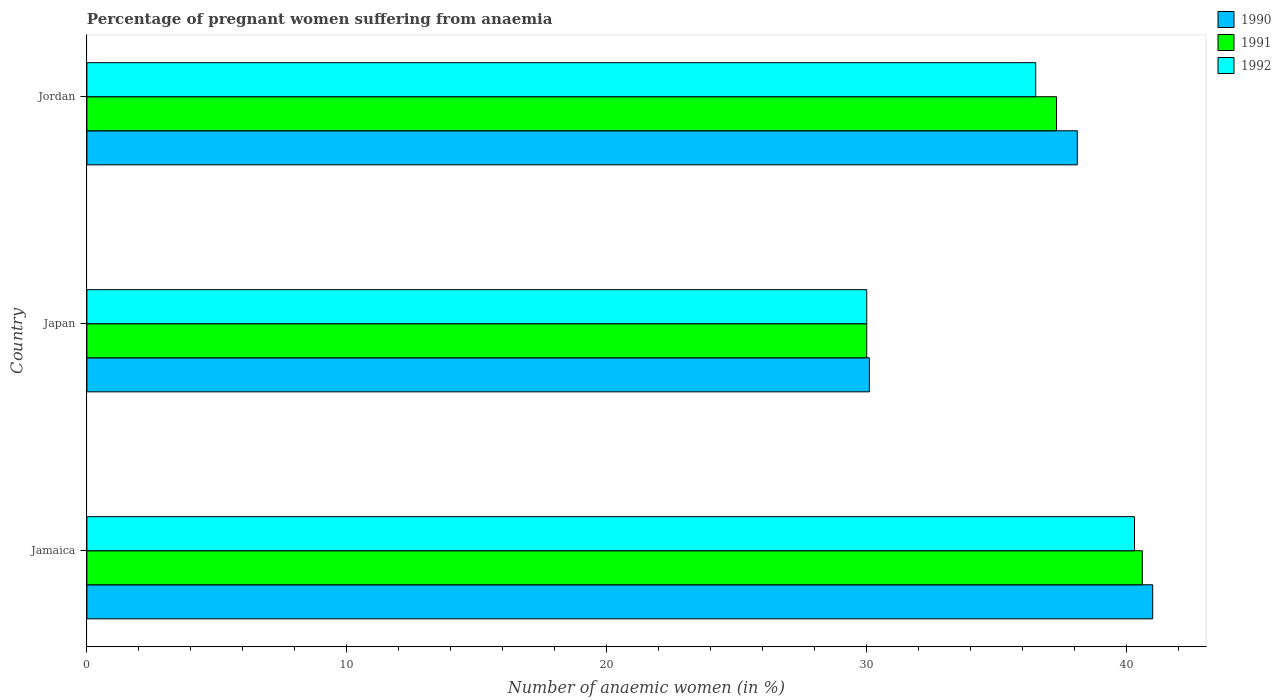How many groups of bars are there?
Make the answer very short. 3. How many bars are there on the 1st tick from the top?
Your response must be concise. 3. What is the label of the 1st group of bars from the top?
Your answer should be compact. Jordan. What is the number of anaemic women in 1990 in Jamaica?
Your answer should be compact. 41. Across all countries, what is the maximum number of anaemic women in 1992?
Ensure brevity in your answer.  40.3. Across all countries, what is the minimum number of anaemic women in 1990?
Your response must be concise. 30.1. In which country was the number of anaemic women in 1991 maximum?
Make the answer very short. Jamaica. What is the total number of anaemic women in 1992 in the graph?
Your answer should be very brief. 106.8. What is the difference between the number of anaemic women in 1991 in Jamaica and that in Jordan?
Your answer should be very brief. 3.3. What is the difference between the number of anaemic women in 1990 in Jordan and the number of anaemic women in 1992 in Japan?
Your answer should be very brief. 8.1. What is the average number of anaemic women in 1991 per country?
Offer a terse response. 35.97. What is the difference between the number of anaemic women in 1992 and number of anaemic women in 1990 in Jamaica?
Give a very brief answer. -0.7. In how many countries, is the number of anaemic women in 1992 greater than 14 %?
Your answer should be very brief. 3. What is the ratio of the number of anaemic women in 1990 in Jamaica to that in Jordan?
Your response must be concise. 1.08. Is the number of anaemic women in 1991 in Jamaica less than that in Jordan?
Keep it short and to the point. No. Is the difference between the number of anaemic women in 1992 in Japan and Jordan greater than the difference between the number of anaemic women in 1990 in Japan and Jordan?
Your answer should be very brief. Yes. What is the difference between the highest and the second highest number of anaemic women in 1991?
Offer a terse response. 3.3. What is the difference between the highest and the lowest number of anaemic women in 1992?
Provide a short and direct response. 10.3. In how many countries, is the number of anaemic women in 1990 greater than the average number of anaemic women in 1990 taken over all countries?
Your answer should be very brief. 2. Are all the bars in the graph horizontal?
Ensure brevity in your answer.  Yes. What is the difference between two consecutive major ticks on the X-axis?
Give a very brief answer. 10. Does the graph contain grids?
Keep it short and to the point. No. Where does the legend appear in the graph?
Your answer should be compact. Top right. How many legend labels are there?
Offer a terse response. 3. How are the legend labels stacked?
Give a very brief answer. Vertical. What is the title of the graph?
Keep it short and to the point. Percentage of pregnant women suffering from anaemia. Does "1988" appear as one of the legend labels in the graph?
Your response must be concise. No. What is the label or title of the X-axis?
Your answer should be very brief. Number of anaemic women (in %). What is the Number of anaemic women (in %) of 1991 in Jamaica?
Ensure brevity in your answer.  40.6. What is the Number of anaemic women (in %) in 1992 in Jamaica?
Your answer should be very brief. 40.3. What is the Number of anaemic women (in %) in 1990 in Japan?
Offer a terse response. 30.1. What is the Number of anaemic women (in %) in 1990 in Jordan?
Provide a short and direct response. 38.1. What is the Number of anaemic women (in %) of 1991 in Jordan?
Ensure brevity in your answer.  37.3. What is the Number of anaemic women (in %) of 1992 in Jordan?
Give a very brief answer. 36.5. Across all countries, what is the maximum Number of anaemic women (in %) of 1991?
Offer a terse response. 40.6. Across all countries, what is the maximum Number of anaemic women (in %) of 1992?
Give a very brief answer. 40.3. Across all countries, what is the minimum Number of anaemic women (in %) of 1990?
Keep it short and to the point. 30.1. Across all countries, what is the minimum Number of anaemic women (in %) in 1992?
Your answer should be compact. 30. What is the total Number of anaemic women (in %) of 1990 in the graph?
Your response must be concise. 109.2. What is the total Number of anaemic women (in %) in 1991 in the graph?
Your answer should be very brief. 107.9. What is the total Number of anaemic women (in %) of 1992 in the graph?
Your answer should be very brief. 106.8. What is the difference between the Number of anaemic women (in %) of 1990 in Jamaica and that in Jordan?
Make the answer very short. 2.9. What is the difference between the Number of anaemic women (in %) in 1990 in Japan and that in Jordan?
Provide a succinct answer. -8. What is the difference between the Number of anaemic women (in %) of 1991 in Japan and that in Jordan?
Provide a short and direct response. -7.3. What is the difference between the Number of anaemic women (in %) in 1992 in Japan and that in Jordan?
Give a very brief answer. -6.5. What is the difference between the Number of anaemic women (in %) in 1991 in Jamaica and the Number of anaemic women (in %) in 1992 in Japan?
Ensure brevity in your answer.  10.6. What is the difference between the Number of anaemic women (in %) in 1990 in Jamaica and the Number of anaemic women (in %) in 1991 in Jordan?
Offer a terse response. 3.7. What is the difference between the Number of anaemic women (in %) in 1991 in Jamaica and the Number of anaemic women (in %) in 1992 in Jordan?
Offer a very short reply. 4.1. What is the difference between the Number of anaemic women (in %) of 1991 in Japan and the Number of anaemic women (in %) of 1992 in Jordan?
Keep it short and to the point. -6.5. What is the average Number of anaemic women (in %) in 1990 per country?
Your response must be concise. 36.4. What is the average Number of anaemic women (in %) in 1991 per country?
Your answer should be compact. 35.97. What is the average Number of anaemic women (in %) in 1992 per country?
Make the answer very short. 35.6. What is the difference between the Number of anaemic women (in %) in 1990 and Number of anaemic women (in %) in 1991 in Jamaica?
Your response must be concise. 0.4. What is the difference between the Number of anaemic women (in %) in 1991 and Number of anaemic women (in %) in 1992 in Japan?
Keep it short and to the point. 0. What is the difference between the Number of anaemic women (in %) of 1990 and Number of anaemic women (in %) of 1992 in Jordan?
Make the answer very short. 1.6. What is the difference between the Number of anaemic women (in %) of 1991 and Number of anaemic women (in %) of 1992 in Jordan?
Make the answer very short. 0.8. What is the ratio of the Number of anaemic women (in %) in 1990 in Jamaica to that in Japan?
Your response must be concise. 1.36. What is the ratio of the Number of anaemic women (in %) in 1991 in Jamaica to that in Japan?
Your response must be concise. 1.35. What is the ratio of the Number of anaemic women (in %) in 1992 in Jamaica to that in Japan?
Provide a short and direct response. 1.34. What is the ratio of the Number of anaemic women (in %) of 1990 in Jamaica to that in Jordan?
Ensure brevity in your answer.  1.08. What is the ratio of the Number of anaemic women (in %) in 1991 in Jamaica to that in Jordan?
Provide a succinct answer. 1.09. What is the ratio of the Number of anaemic women (in %) of 1992 in Jamaica to that in Jordan?
Your answer should be very brief. 1.1. What is the ratio of the Number of anaemic women (in %) in 1990 in Japan to that in Jordan?
Give a very brief answer. 0.79. What is the ratio of the Number of anaemic women (in %) of 1991 in Japan to that in Jordan?
Your answer should be compact. 0.8. What is the ratio of the Number of anaemic women (in %) of 1992 in Japan to that in Jordan?
Your response must be concise. 0.82. What is the difference between the highest and the second highest Number of anaemic women (in %) of 1990?
Offer a terse response. 2.9. What is the difference between the highest and the second highest Number of anaemic women (in %) in 1991?
Offer a very short reply. 3.3. What is the difference between the highest and the lowest Number of anaemic women (in %) in 1990?
Give a very brief answer. 10.9. What is the difference between the highest and the lowest Number of anaemic women (in %) in 1991?
Offer a very short reply. 10.6. What is the difference between the highest and the lowest Number of anaemic women (in %) of 1992?
Offer a very short reply. 10.3. 